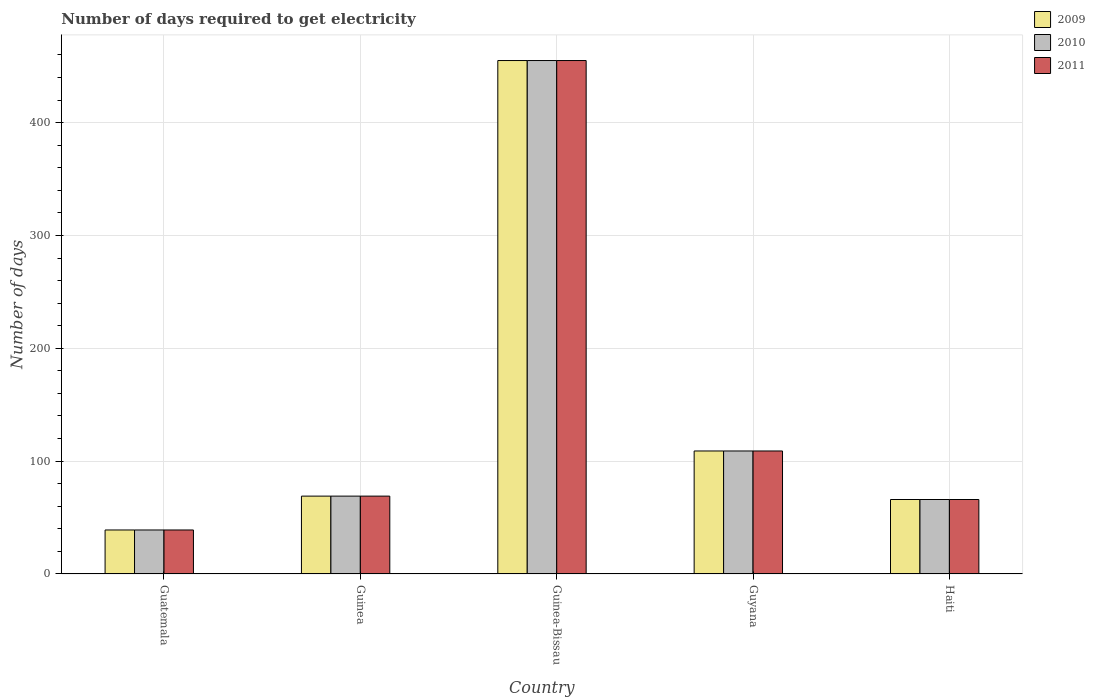Are the number of bars on each tick of the X-axis equal?
Provide a short and direct response. Yes. What is the label of the 2nd group of bars from the left?
Keep it short and to the point. Guinea. In how many cases, is the number of bars for a given country not equal to the number of legend labels?
Provide a short and direct response. 0. Across all countries, what is the maximum number of days required to get electricity in in 2010?
Keep it short and to the point. 455. In which country was the number of days required to get electricity in in 2011 maximum?
Give a very brief answer. Guinea-Bissau. In which country was the number of days required to get electricity in in 2009 minimum?
Offer a very short reply. Guatemala. What is the total number of days required to get electricity in in 2011 in the graph?
Your answer should be very brief. 738. What is the difference between the number of days required to get electricity in in 2010 in Guinea and that in Guinea-Bissau?
Keep it short and to the point. -386. What is the difference between the number of days required to get electricity in in 2009 in Guinea-Bissau and the number of days required to get electricity in in 2011 in Guyana?
Ensure brevity in your answer.  346. What is the average number of days required to get electricity in in 2009 per country?
Make the answer very short. 147.6. What is the difference between the number of days required to get electricity in of/in 2011 and number of days required to get electricity in of/in 2010 in Guyana?
Make the answer very short. 0. What is the ratio of the number of days required to get electricity in in 2010 in Guinea to that in Guinea-Bissau?
Make the answer very short. 0.15. Is the difference between the number of days required to get electricity in in 2011 in Guatemala and Guyana greater than the difference between the number of days required to get electricity in in 2010 in Guatemala and Guyana?
Provide a short and direct response. No. What is the difference between the highest and the lowest number of days required to get electricity in in 2011?
Provide a short and direct response. 416. Is the sum of the number of days required to get electricity in in 2010 in Guinea and Guinea-Bissau greater than the maximum number of days required to get electricity in in 2009 across all countries?
Ensure brevity in your answer.  Yes. How many bars are there?
Ensure brevity in your answer.  15. Are all the bars in the graph horizontal?
Provide a succinct answer. No. How many legend labels are there?
Ensure brevity in your answer.  3. What is the title of the graph?
Give a very brief answer. Number of days required to get electricity. What is the label or title of the Y-axis?
Keep it short and to the point. Number of days. What is the Number of days of 2009 in Guatemala?
Ensure brevity in your answer.  39. What is the Number of days in 2011 in Guatemala?
Make the answer very short. 39. What is the Number of days in 2009 in Guinea?
Provide a short and direct response. 69. What is the Number of days in 2010 in Guinea?
Keep it short and to the point. 69. What is the Number of days in 2011 in Guinea?
Keep it short and to the point. 69. What is the Number of days in 2009 in Guinea-Bissau?
Provide a succinct answer. 455. What is the Number of days of 2010 in Guinea-Bissau?
Offer a terse response. 455. What is the Number of days in 2011 in Guinea-Bissau?
Provide a succinct answer. 455. What is the Number of days in 2009 in Guyana?
Provide a succinct answer. 109. What is the Number of days in 2010 in Guyana?
Provide a short and direct response. 109. What is the Number of days in 2011 in Guyana?
Keep it short and to the point. 109. What is the Number of days in 2009 in Haiti?
Your answer should be compact. 66. What is the Number of days in 2010 in Haiti?
Your answer should be compact. 66. Across all countries, what is the maximum Number of days in 2009?
Keep it short and to the point. 455. Across all countries, what is the maximum Number of days of 2010?
Make the answer very short. 455. Across all countries, what is the maximum Number of days in 2011?
Offer a very short reply. 455. Across all countries, what is the minimum Number of days of 2010?
Your answer should be compact. 39. Across all countries, what is the minimum Number of days in 2011?
Give a very brief answer. 39. What is the total Number of days in 2009 in the graph?
Offer a very short reply. 738. What is the total Number of days of 2010 in the graph?
Make the answer very short. 738. What is the total Number of days of 2011 in the graph?
Keep it short and to the point. 738. What is the difference between the Number of days in 2011 in Guatemala and that in Guinea?
Make the answer very short. -30. What is the difference between the Number of days in 2009 in Guatemala and that in Guinea-Bissau?
Make the answer very short. -416. What is the difference between the Number of days of 2010 in Guatemala and that in Guinea-Bissau?
Ensure brevity in your answer.  -416. What is the difference between the Number of days of 2011 in Guatemala and that in Guinea-Bissau?
Make the answer very short. -416. What is the difference between the Number of days in 2009 in Guatemala and that in Guyana?
Provide a short and direct response. -70. What is the difference between the Number of days of 2010 in Guatemala and that in Guyana?
Your answer should be compact. -70. What is the difference between the Number of days of 2011 in Guatemala and that in Guyana?
Offer a terse response. -70. What is the difference between the Number of days of 2009 in Guatemala and that in Haiti?
Provide a succinct answer. -27. What is the difference between the Number of days in 2010 in Guatemala and that in Haiti?
Your answer should be compact. -27. What is the difference between the Number of days in 2009 in Guinea and that in Guinea-Bissau?
Your answer should be very brief. -386. What is the difference between the Number of days of 2010 in Guinea and that in Guinea-Bissau?
Keep it short and to the point. -386. What is the difference between the Number of days in 2011 in Guinea and that in Guinea-Bissau?
Your answer should be compact. -386. What is the difference between the Number of days in 2009 in Guinea and that in Haiti?
Offer a terse response. 3. What is the difference between the Number of days in 2009 in Guinea-Bissau and that in Guyana?
Provide a short and direct response. 346. What is the difference between the Number of days of 2010 in Guinea-Bissau and that in Guyana?
Provide a short and direct response. 346. What is the difference between the Number of days of 2011 in Guinea-Bissau and that in Guyana?
Provide a succinct answer. 346. What is the difference between the Number of days in 2009 in Guinea-Bissau and that in Haiti?
Provide a succinct answer. 389. What is the difference between the Number of days of 2010 in Guinea-Bissau and that in Haiti?
Your answer should be compact. 389. What is the difference between the Number of days of 2011 in Guinea-Bissau and that in Haiti?
Your answer should be very brief. 389. What is the difference between the Number of days of 2010 in Guatemala and the Number of days of 2011 in Guinea?
Offer a terse response. -30. What is the difference between the Number of days in 2009 in Guatemala and the Number of days in 2010 in Guinea-Bissau?
Your answer should be compact. -416. What is the difference between the Number of days of 2009 in Guatemala and the Number of days of 2011 in Guinea-Bissau?
Your answer should be compact. -416. What is the difference between the Number of days of 2010 in Guatemala and the Number of days of 2011 in Guinea-Bissau?
Your response must be concise. -416. What is the difference between the Number of days in 2009 in Guatemala and the Number of days in 2010 in Guyana?
Offer a terse response. -70. What is the difference between the Number of days of 2009 in Guatemala and the Number of days of 2011 in Guyana?
Provide a short and direct response. -70. What is the difference between the Number of days of 2010 in Guatemala and the Number of days of 2011 in Guyana?
Your response must be concise. -70. What is the difference between the Number of days of 2009 in Guatemala and the Number of days of 2010 in Haiti?
Offer a terse response. -27. What is the difference between the Number of days of 2009 in Guinea and the Number of days of 2010 in Guinea-Bissau?
Your answer should be very brief. -386. What is the difference between the Number of days of 2009 in Guinea and the Number of days of 2011 in Guinea-Bissau?
Give a very brief answer. -386. What is the difference between the Number of days of 2010 in Guinea and the Number of days of 2011 in Guinea-Bissau?
Make the answer very short. -386. What is the difference between the Number of days of 2009 in Guinea and the Number of days of 2011 in Guyana?
Provide a short and direct response. -40. What is the difference between the Number of days of 2009 in Guinea and the Number of days of 2010 in Haiti?
Give a very brief answer. 3. What is the difference between the Number of days in 2009 in Guinea-Bissau and the Number of days in 2010 in Guyana?
Your answer should be compact. 346. What is the difference between the Number of days of 2009 in Guinea-Bissau and the Number of days of 2011 in Guyana?
Ensure brevity in your answer.  346. What is the difference between the Number of days in 2010 in Guinea-Bissau and the Number of days in 2011 in Guyana?
Offer a very short reply. 346. What is the difference between the Number of days in 2009 in Guinea-Bissau and the Number of days in 2010 in Haiti?
Keep it short and to the point. 389. What is the difference between the Number of days in 2009 in Guinea-Bissau and the Number of days in 2011 in Haiti?
Give a very brief answer. 389. What is the difference between the Number of days in 2010 in Guinea-Bissau and the Number of days in 2011 in Haiti?
Your answer should be compact. 389. What is the difference between the Number of days in 2009 in Guyana and the Number of days in 2010 in Haiti?
Keep it short and to the point. 43. What is the average Number of days of 2009 per country?
Your answer should be compact. 147.6. What is the average Number of days of 2010 per country?
Give a very brief answer. 147.6. What is the average Number of days of 2011 per country?
Your answer should be compact. 147.6. What is the difference between the Number of days of 2009 and Number of days of 2010 in Guatemala?
Provide a succinct answer. 0. What is the difference between the Number of days in 2009 and Number of days in 2011 in Guatemala?
Ensure brevity in your answer.  0. What is the difference between the Number of days of 2010 and Number of days of 2011 in Guatemala?
Offer a very short reply. 0. What is the difference between the Number of days of 2009 and Number of days of 2011 in Guinea-Bissau?
Provide a succinct answer. 0. What is the difference between the Number of days of 2009 and Number of days of 2011 in Guyana?
Provide a succinct answer. 0. What is the difference between the Number of days of 2010 and Number of days of 2011 in Guyana?
Give a very brief answer. 0. What is the difference between the Number of days in 2009 and Number of days in 2010 in Haiti?
Provide a short and direct response. 0. What is the difference between the Number of days of 2009 and Number of days of 2011 in Haiti?
Keep it short and to the point. 0. What is the ratio of the Number of days in 2009 in Guatemala to that in Guinea?
Offer a very short reply. 0.57. What is the ratio of the Number of days in 2010 in Guatemala to that in Guinea?
Give a very brief answer. 0.57. What is the ratio of the Number of days of 2011 in Guatemala to that in Guinea?
Offer a terse response. 0.57. What is the ratio of the Number of days in 2009 in Guatemala to that in Guinea-Bissau?
Ensure brevity in your answer.  0.09. What is the ratio of the Number of days of 2010 in Guatemala to that in Guinea-Bissau?
Offer a terse response. 0.09. What is the ratio of the Number of days of 2011 in Guatemala to that in Guinea-Bissau?
Offer a terse response. 0.09. What is the ratio of the Number of days in 2009 in Guatemala to that in Guyana?
Your response must be concise. 0.36. What is the ratio of the Number of days of 2010 in Guatemala to that in Guyana?
Offer a terse response. 0.36. What is the ratio of the Number of days of 2011 in Guatemala to that in Guyana?
Offer a very short reply. 0.36. What is the ratio of the Number of days in 2009 in Guatemala to that in Haiti?
Make the answer very short. 0.59. What is the ratio of the Number of days of 2010 in Guatemala to that in Haiti?
Your answer should be compact. 0.59. What is the ratio of the Number of days of 2011 in Guatemala to that in Haiti?
Your answer should be very brief. 0.59. What is the ratio of the Number of days of 2009 in Guinea to that in Guinea-Bissau?
Ensure brevity in your answer.  0.15. What is the ratio of the Number of days in 2010 in Guinea to that in Guinea-Bissau?
Make the answer very short. 0.15. What is the ratio of the Number of days in 2011 in Guinea to that in Guinea-Bissau?
Your answer should be compact. 0.15. What is the ratio of the Number of days in 2009 in Guinea to that in Guyana?
Provide a short and direct response. 0.63. What is the ratio of the Number of days of 2010 in Guinea to that in Guyana?
Offer a terse response. 0.63. What is the ratio of the Number of days in 2011 in Guinea to that in Guyana?
Your response must be concise. 0.63. What is the ratio of the Number of days in 2009 in Guinea to that in Haiti?
Ensure brevity in your answer.  1.05. What is the ratio of the Number of days of 2010 in Guinea to that in Haiti?
Ensure brevity in your answer.  1.05. What is the ratio of the Number of days in 2011 in Guinea to that in Haiti?
Offer a terse response. 1.05. What is the ratio of the Number of days in 2009 in Guinea-Bissau to that in Guyana?
Keep it short and to the point. 4.17. What is the ratio of the Number of days in 2010 in Guinea-Bissau to that in Guyana?
Your answer should be compact. 4.17. What is the ratio of the Number of days in 2011 in Guinea-Bissau to that in Guyana?
Offer a very short reply. 4.17. What is the ratio of the Number of days in 2009 in Guinea-Bissau to that in Haiti?
Offer a very short reply. 6.89. What is the ratio of the Number of days in 2010 in Guinea-Bissau to that in Haiti?
Provide a short and direct response. 6.89. What is the ratio of the Number of days in 2011 in Guinea-Bissau to that in Haiti?
Give a very brief answer. 6.89. What is the ratio of the Number of days in 2009 in Guyana to that in Haiti?
Ensure brevity in your answer.  1.65. What is the ratio of the Number of days in 2010 in Guyana to that in Haiti?
Provide a succinct answer. 1.65. What is the ratio of the Number of days of 2011 in Guyana to that in Haiti?
Your answer should be very brief. 1.65. What is the difference between the highest and the second highest Number of days in 2009?
Your answer should be compact. 346. What is the difference between the highest and the second highest Number of days in 2010?
Provide a succinct answer. 346. What is the difference between the highest and the second highest Number of days in 2011?
Your answer should be very brief. 346. What is the difference between the highest and the lowest Number of days in 2009?
Ensure brevity in your answer.  416. What is the difference between the highest and the lowest Number of days in 2010?
Your answer should be compact. 416. What is the difference between the highest and the lowest Number of days of 2011?
Give a very brief answer. 416. 